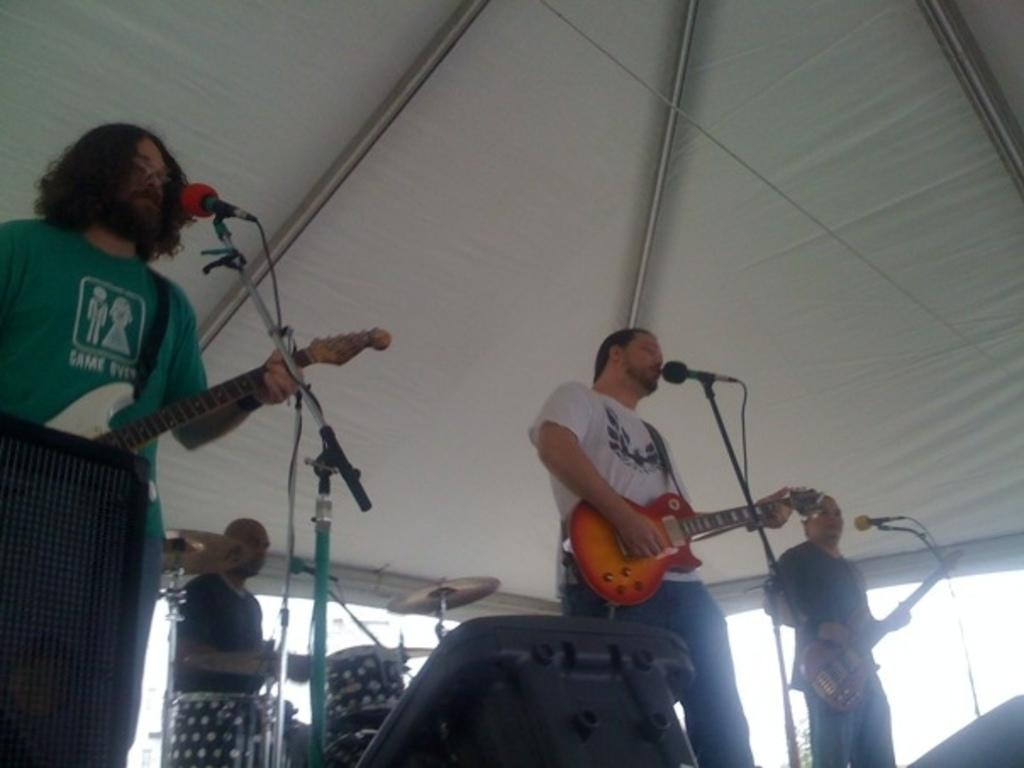How many people are in the image? There are four people in the image. What are three of the people doing in the image? Three of the people are playing guitar and singing a song. What equipment is set up in front of the musicians? There are microphones and mic stands in front of the musicians. What instrument is the fourth person playing in the image? The fourth person is playing drums behind the musicians. What type of rice can be seen cooking in a pot in the image? There is no rice or pot visible in the image; it features people playing musical instruments. Is there a flame visible in the image? No, there is no flame visible in the image. 